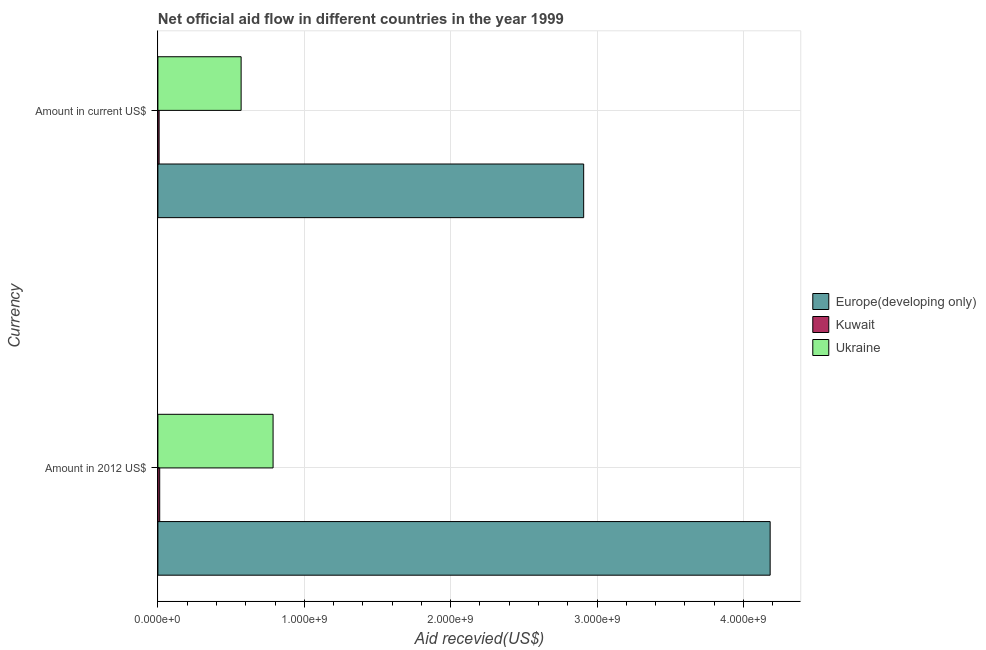Are the number of bars per tick equal to the number of legend labels?
Your answer should be very brief. Yes. What is the label of the 1st group of bars from the top?
Keep it short and to the point. Amount in current US$. What is the amount of aid received(expressed in 2012 us$) in Europe(developing only)?
Give a very brief answer. 4.18e+09. Across all countries, what is the maximum amount of aid received(expressed in us$)?
Ensure brevity in your answer.  2.91e+09. Across all countries, what is the minimum amount of aid received(expressed in us$)?
Give a very brief answer. 8.33e+06. In which country was the amount of aid received(expressed in 2012 us$) maximum?
Offer a very short reply. Europe(developing only). In which country was the amount of aid received(expressed in 2012 us$) minimum?
Offer a terse response. Kuwait. What is the total amount of aid received(expressed in 2012 us$) in the graph?
Your answer should be compact. 4.98e+09. What is the difference between the amount of aid received(expressed in us$) in Europe(developing only) and that in Ukraine?
Make the answer very short. 2.34e+09. What is the difference between the amount of aid received(expressed in 2012 us$) in Ukraine and the amount of aid received(expressed in us$) in Europe(developing only)?
Provide a short and direct response. -2.12e+09. What is the average amount of aid received(expressed in 2012 us$) per country?
Provide a succinct answer. 1.66e+09. What is the difference between the amount of aid received(expressed in 2012 us$) and amount of aid received(expressed in us$) in Ukraine?
Your response must be concise. 2.18e+08. What is the ratio of the amount of aid received(expressed in 2012 us$) in Ukraine to that in Europe(developing only)?
Provide a succinct answer. 0.19. Is the amount of aid received(expressed in us$) in Europe(developing only) less than that in Ukraine?
Provide a short and direct response. No. In how many countries, is the amount of aid received(expressed in 2012 us$) greater than the average amount of aid received(expressed in 2012 us$) taken over all countries?
Give a very brief answer. 1. What does the 1st bar from the top in Amount in 2012 US$ represents?
Provide a succinct answer. Ukraine. What does the 3rd bar from the bottom in Amount in 2012 US$ represents?
Keep it short and to the point. Ukraine. How many bars are there?
Make the answer very short. 6. How many countries are there in the graph?
Keep it short and to the point. 3. What is the difference between two consecutive major ticks on the X-axis?
Make the answer very short. 1.00e+09. What is the title of the graph?
Your answer should be compact. Net official aid flow in different countries in the year 1999. What is the label or title of the X-axis?
Provide a succinct answer. Aid recevied(US$). What is the label or title of the Y-axis?
Your response must be concise. Currency. What is the Aid recevied(US$) of Europe(developing only) in Amount in 2012 US$?
Provide a succinct answer. 4.18e+09. What is the Aid recevied(US$) of Kuwait in Amount in 2012 US$?
Make the answer very short. 1.23e+07. What is the Aid recevied(US$) of Ukraine in Amount in 2012 US$?
Make the answer very short. 7.87e+08. What is the Aid recevied(US$) in Europe(developing only) in Amount in current US$?
Give a very brief answer. 2.91e+09. What is the Aid recevied(US$) of Kuwait in Amount in current US$?
Offer a very short reply. 8.33e+06. What is the Aid recevied(US$) of Ukraine in Amount in current US$?
Ensure brevity in your answer.  5.69e+08. Across all Currency, what is the maximum Aid recevied(US$) in Europe(developing only)?
Offer a very short reply. 4.18e+09. Across all Currency, what is the maximum Aid recevied(US$) of Kuwait?
Your response must be concise. 1.23e+07. Across all Currency, what is the maximum Aid recevied(US$) in Ukraine?
Make the answer very short. 7.87e+08. Across all Currency, what is the minimum Aid recevied(US$) of Europe(developing only)?
Provide a succinct answer. 2.91e+09. Across all Currency, what is the minimum Aid recevied(US$) in Kuwait?
Offer a terse response. 8.33e+06. Across all Currency, what is the minimum Aid recevied(US$) of Ukraine?
Ensure brevity in your answer.  5.69e+08. What is the total Aid recevied(US$) of Europe(developing only) in the graph?
Make the answer very short. 7.09e+09. What is the total Aid recevied(US$) of Kuwait in the graph?
Provide a succinct answer. 2.07e+07. What is the total Aid recevied(US$) in Ukraine in the graph?
Your answer should be very brief. 1.36e+09. What is the difference between the Aid recevied(US$) of Europe(developing only) in Amount in 2012 US$ and that in Amount in current US$?
Your answer should be compact. 1.27e+09. What is the difference between the Aid recevied(US$) in Ukraine in Amount in 2012 US$ and that in Amount in current US$?
Offer a terse response. 2.18e+08. What is the difference between the Aid recevied(US$) of Europe(developing only) in Amount in 2012 US$ and the Aid recevied(US$) of Kuwait in Amount in current US$?
Provide a short and direct response. 4.17e+09. What is the difference between the Aid recevied(US$) of Europe(developing only) in Amount in 2012 US$ and the Aid recevied(US$) of Ukraine in Amount in current US$?
Offer a terse response. 3.61e+09. What is the difference between the Aid recevied(US$) in Kuwait in Amount in 2012 US$ and the Aid recevied(US$) in Ukraine in Amount in current US$?
Make the answer very short. -5.56e+08. What is the average Aid recevied(US$) of Europe(developing only) per Currency?
Ensure brevity in your answer.  3.55e+09. What is the average Aid recevied(US$) in Kuwait per Currency?
Keep it short and to the point. 1.03e+07. What is the average Aid recevied(US$) of Ukraine per Currency?
Your answer should be compact. 6.78e+08. What is the difference between the Aid recevied(US$) in Europe(developing only) and Aid recevied(US$) in Kuwait in Amount in 2012 US$?
Offer a very short reply. 4.17e+09. What is the difference between the Aid recevied(US$) in Europe(developing only) and Aid recevied(US$) in Ukraine in Amount in 2012 US$?
Ensure brevity in your answer.  3.40e+09. What is the difference between the Aid recevied(US$) of Kuwait and Aid recevied(US$) of Ukraine in Amount in 2012 US$?
Make the answer very short. -7.75e+08. What is the difference between the Aid recevied(US$) of Europe(developing only) and Aid recevied(US$) of Kuwait in Amount in current US$?
Offer a terse response. 2.90e+09. What is the difference between the Aid recevied(US$) of Europe(developing only) and Aid recevied(US$) of Ukraine in Amount in current US$?
Your answer should be very brief. 2.34e+09. What is the difference between the Aid recevied(US$) in Kuwait and Aid recevied(US$) in Ukraine in Amount in current US$?
Offer a very short reply. -5.60e+08. What is the ratio of the Aid recevied(US$) of Europe(developing only) in Amount in 2012 US$ to that in Amount in current US$?
Offer a very short reply. 1.44. What is the ratio of the Aid recevied(US$) in Kuwait in Amount in 2012 US$ to that in Amount in current US$?
Ensure brevity in your answer.  1.48. What is the ratio of the Aid recevied(US$) of Ukraine in Amount in 2012 US$ to that in Amount in current US$?
Make the answer very short. 1.38. What is the difference between the highest and the second highest Aid recevied(US$) in Europe(developing only)?
Provide a short and direct response. 1.27e+09. What is the difference between the highest and the second highest Aid recevied(US$) in Kuwait?
Your answer should be compact. 4.00e+06. What is the difference between the highest and the second highest Aid recevied(US$) of Ukraine?
Provide a short and direct response. 2.18e+08. What is the difference between the highest and the lowest Aid recevied(US$) of Europe(developing only)?
Make the answer very short. 1.27e+09. What is the difference between the highest and the lowest Aid recevied(US$) of Kuwait?
Make the answer very short. 4.00e+06. What is the difference between the highest and the lowest Aid recevied(US$) of Ukraine?
Your answer should be compact. 2.18e+08. 